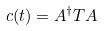<formula> <loc_0><loc_0><loc_500><loc_500>c ( t ) = A ^ { \dagger } T A</formula> 